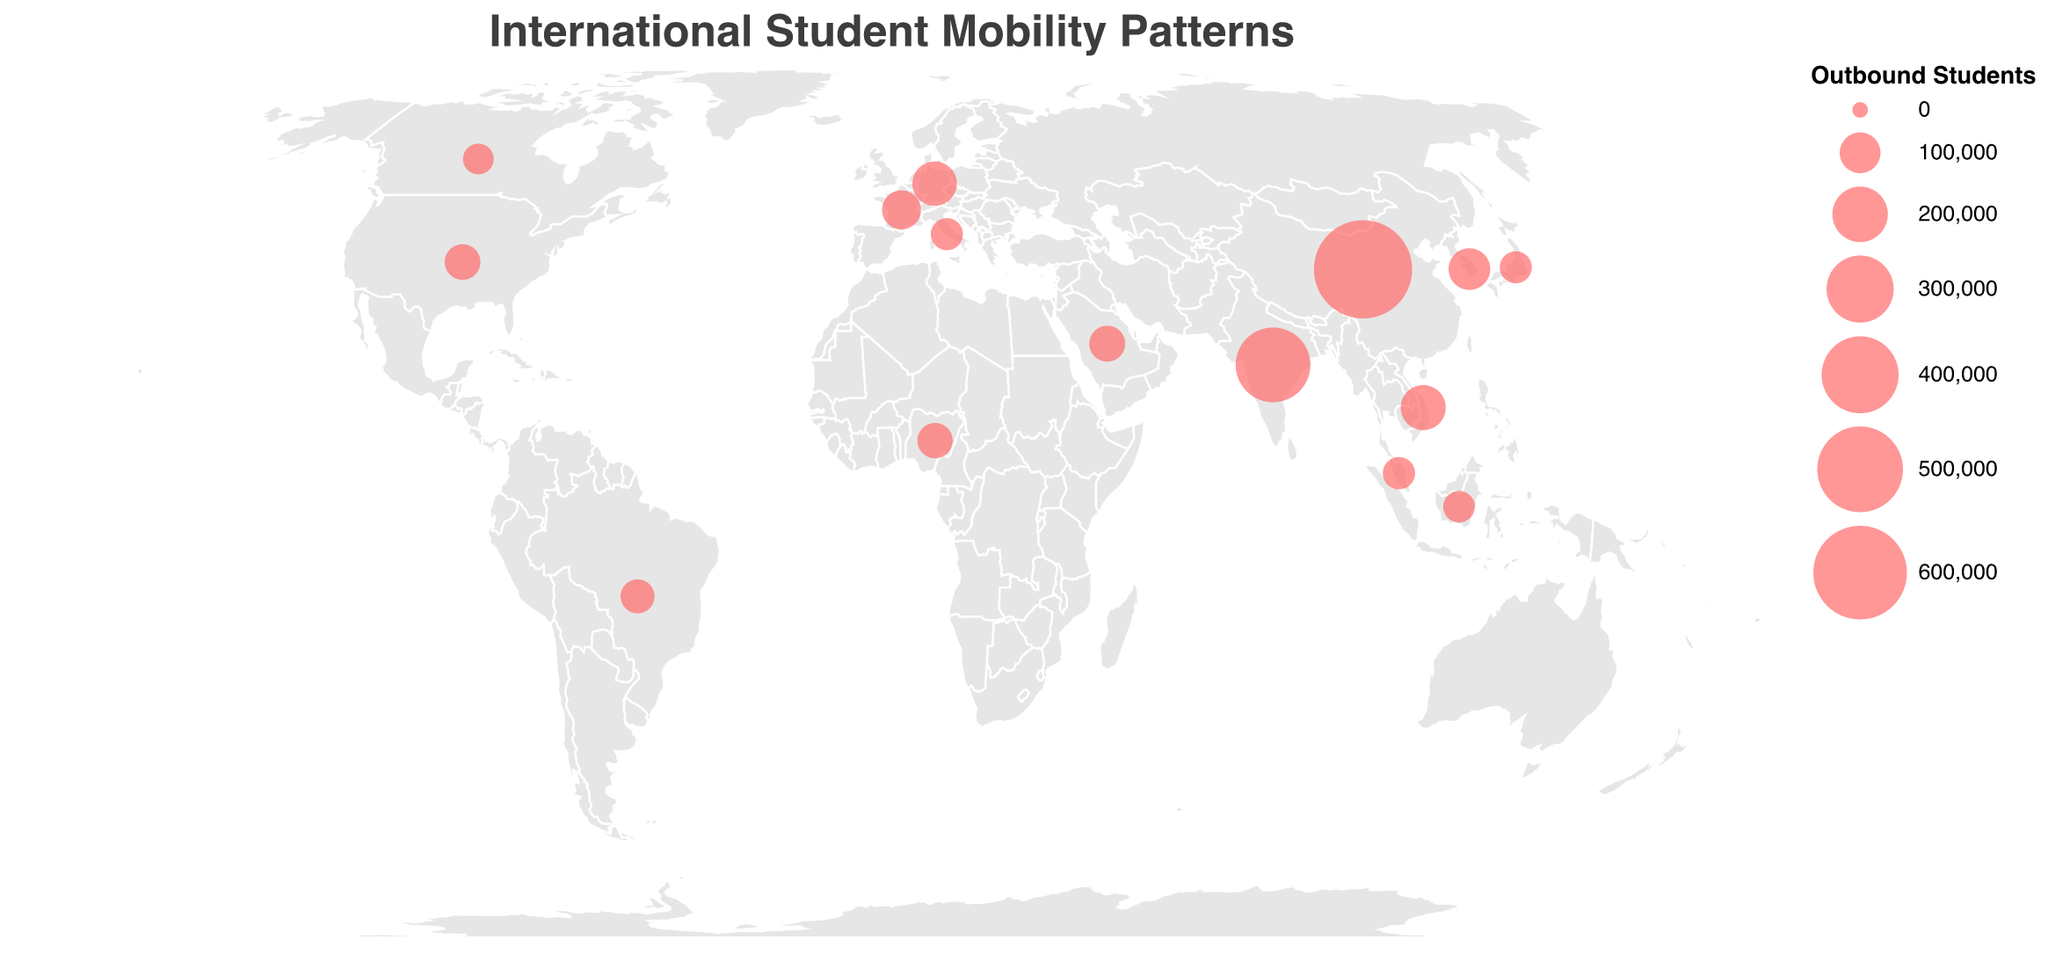What's the title of the figure? Look at the top of the figure, where the title is displayed in larger font size.
Answer: International Student Mobility Patterns What colors are used for the countries and the data points? The fill color of countries on the map is a light gray, and the data points are marked with circles in red.
Answer: Light gray and red Which country has the highest number of outbound students? Find the data point which has the largest circle size, and check its tooltip information for confirmation.
Answer: China How many students are outbound from South Korea? Hover over the circle representing South Korea to display the tooltip information, which includes the number of outbound students.
Answer: 105,400 Compare the number of outbound students from Malaysia and Indonesia. Which one has more? Hover over the circles representing Malaysia and Indonesia to check their tooltip information and compare the outbound student numbers.
Answer: Indonesia List the top three study abroad destinations for Brazil. Hover over the circle representing Brazil on the map and read the tooltip for the top three destinations.
Answer: United States, Portugal, Australia What is the average number of outbound students between Germany, France, and Japan? Extract the number of outbound students for Germany (122,000), France (90,000), and Japan (55,500). Calculate the sum and divide by 3: (122,000 + 90,000 + 55,500) / 3.
Answer: 89,833 How does the number of outbound students from Nigeria compare to the United States? Check the tooltip information for both the countries, noting the number of outbound students from Nigeria (71,000) and the United States (72,700), then compare which number is higher or lower.
Answer: United States has more What projection type is used in the map? The projection type can usually be found in the description at the top of the figure above the map.
Answer: Equal Earth What is the number of outbound students from Saudi Arabia and which are their top three destinations? Hover over the circle representing Saudi Arabia to reveal the tooltip information containing the number of outbound students and their top three destinations.
Answer: 73,900; United States, United Kingdom, Canada 